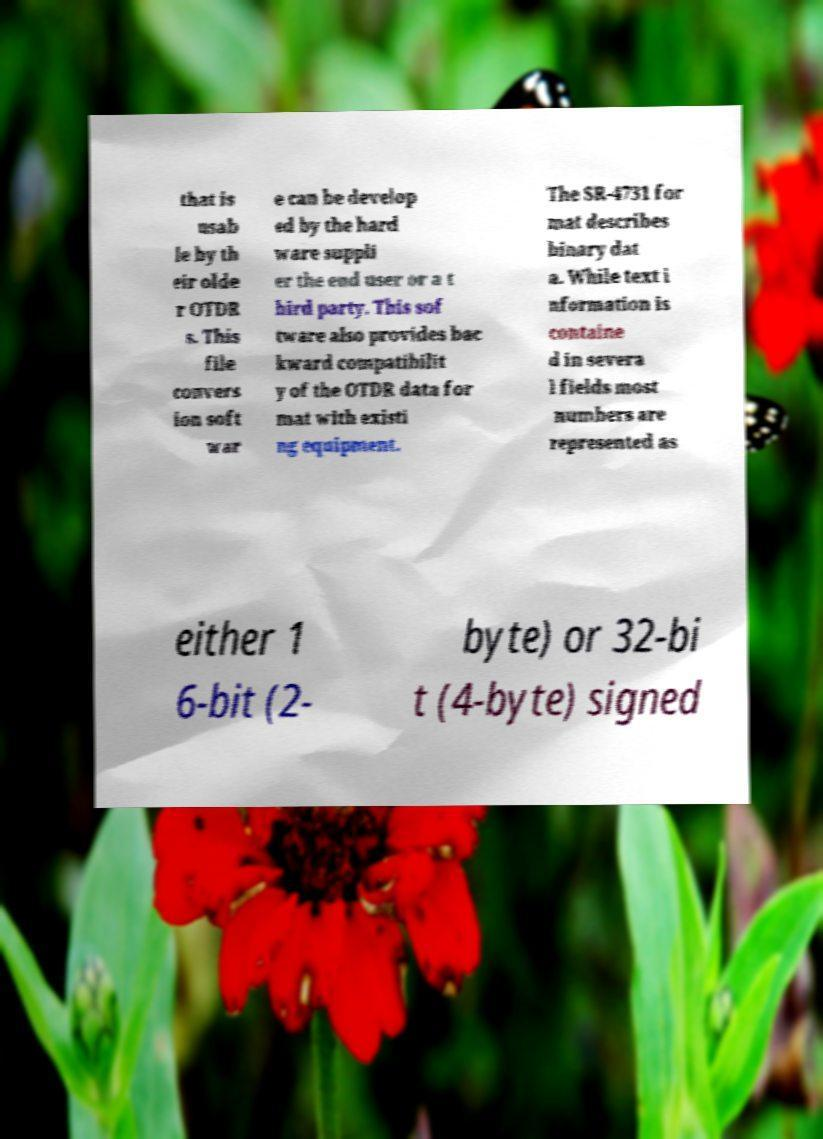For documentation purposes, I need the text within this image transcribed. Could you provide that? that is usab le by th eir olde r OTDR s. This file convers ion soft war e can be develop ed by the hard ware suppli er the end user or a t hird party. This sof tware also provides bac kward compatibilit y of the OTDR data for mat with existi ng equipment. The SR-4731 for mat describes binary dat a. While text i nformation is containe d in severa l fields most numbers are represented as either 1 6-bit (2- byte) or 32-bi t (4-byte) signed 